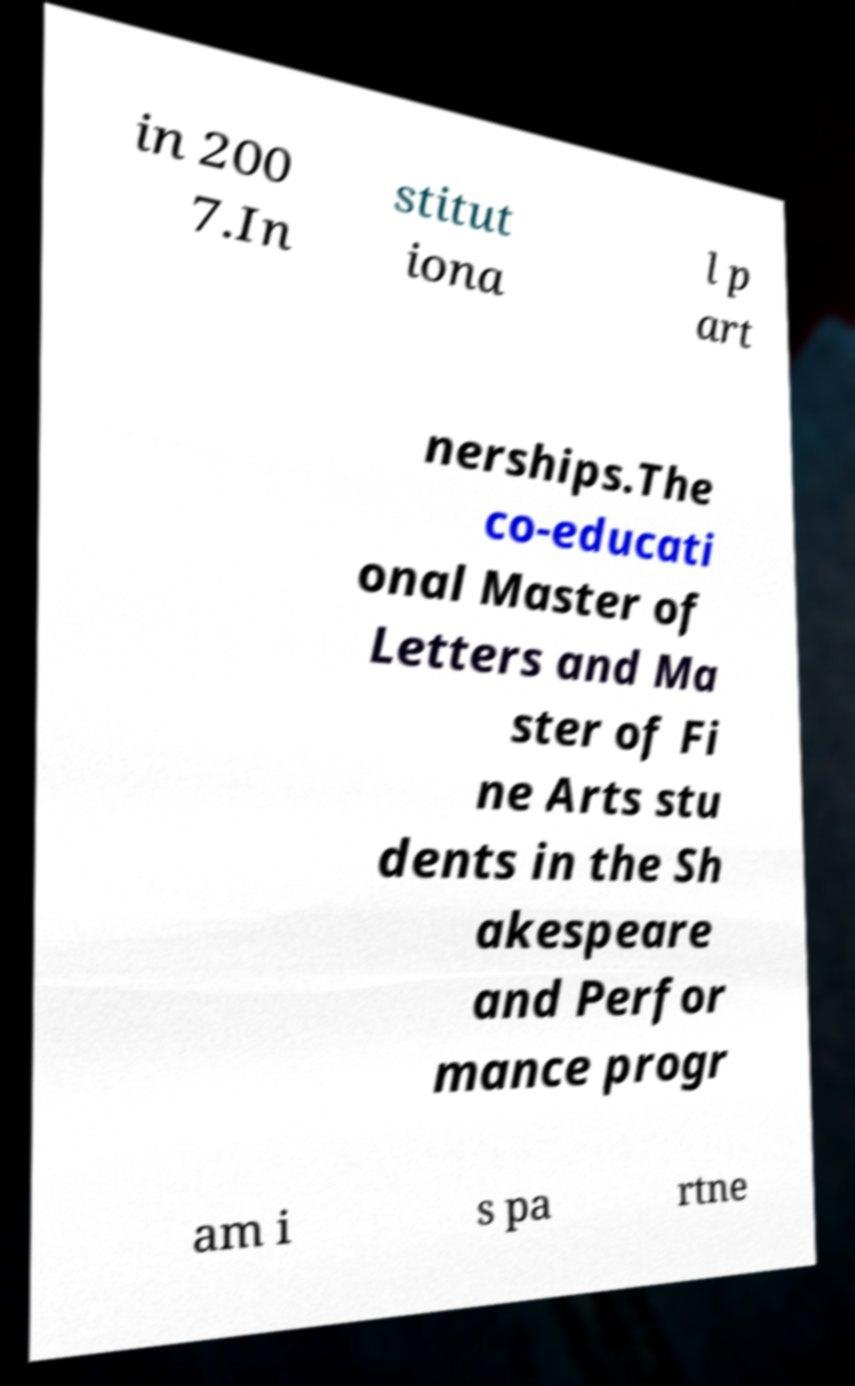Could you assist in decoding the text presented in this image and type it out clearly? in 200 7.In stitut iona l p art nerships.The co-educati onal Master of Letters and Ma ster of Fi ne Arts stu dents in the Sh akespeare and Perfor mance progr am i s pa rtne 